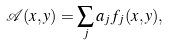<formula> <loc_0><loc_0><loc_500><loc_500>\mathcal { A } ( x , y ) = \sum _ { j } a _ { j } f _ { j } ( x , y ) ,</formula> 